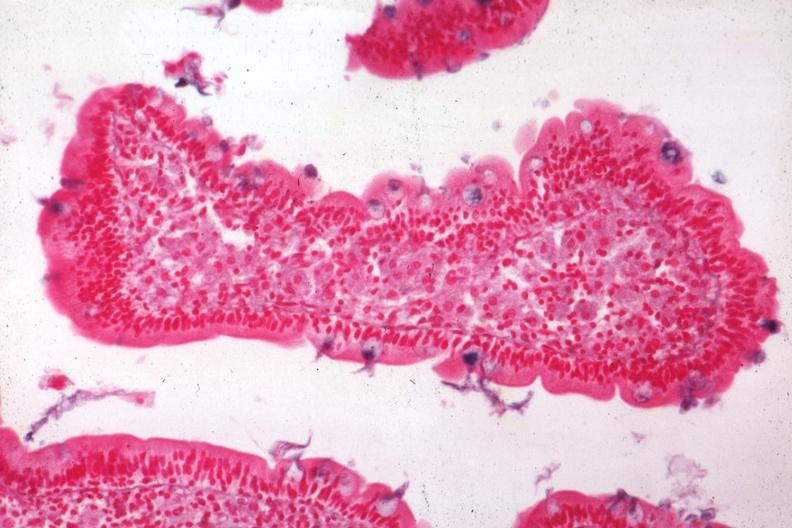does this image show med alcian blue with apparently eosin counterstain enlarged villus with many macrophages source?
Answer the question using a single word or phrase. Yes 